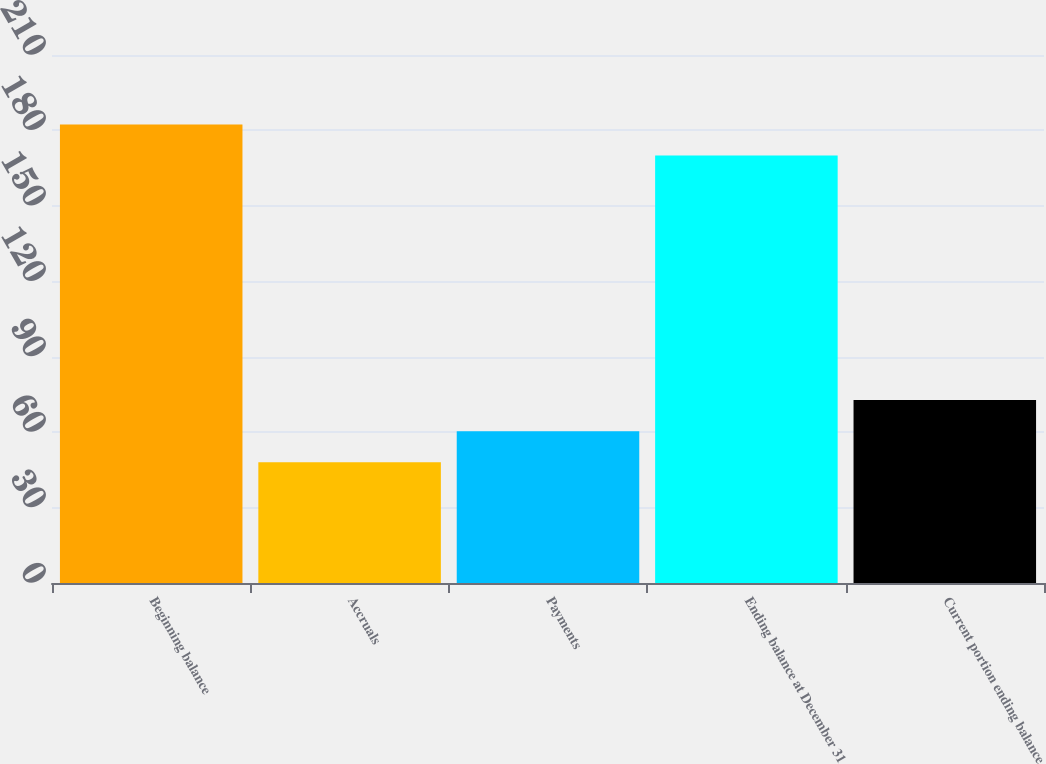Convert chart to OTSL. <chart><loc_0><loc_0><loc_500><loc_500><bar_chart><fcel>Beginning balance<fcel>Accruals<fcel>Payments<fcel>Ending balance at December 31<fcel>Current portion ending balance<nl><fcel>182.4<fcel>48<fcel>60.4<fcel>170<fcel>72.8<nl></chart> 